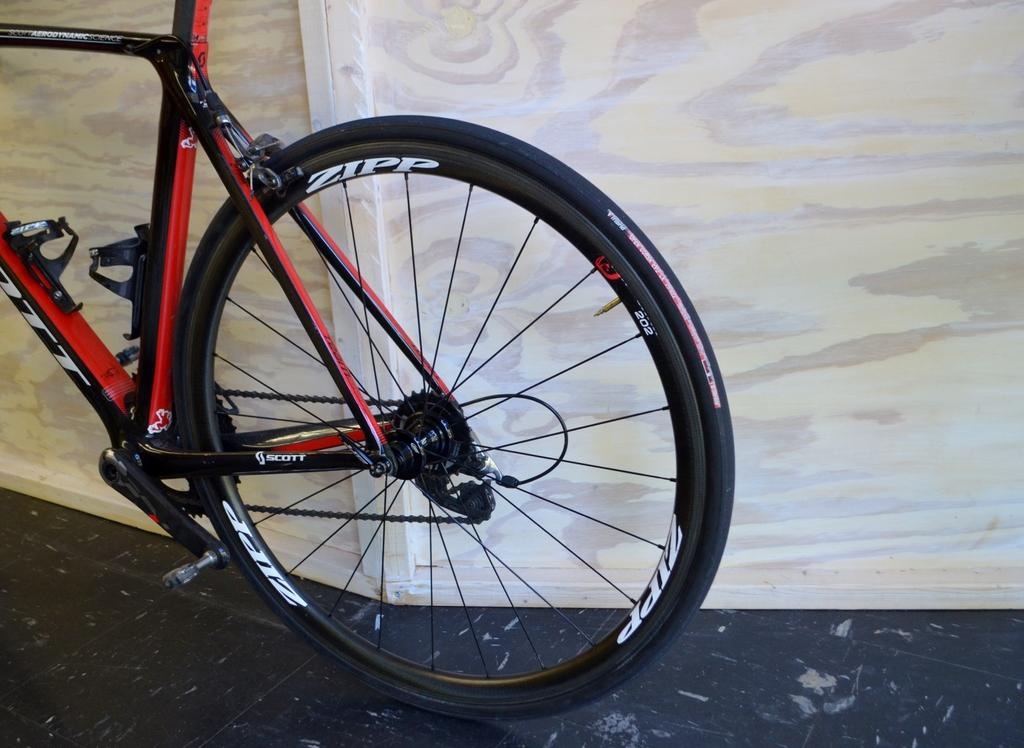What is the main object in the image? There is a bicycle in the image. Is there any text on the bicycle? Yes, there is text written on the bicycle. What can be seen in the background of the image? There is a wooden wall in the background of the image. How many boys are sleeping on the bicycle in the image? There are no boys present in the image, and the bicycle is not being used for sleeping. 